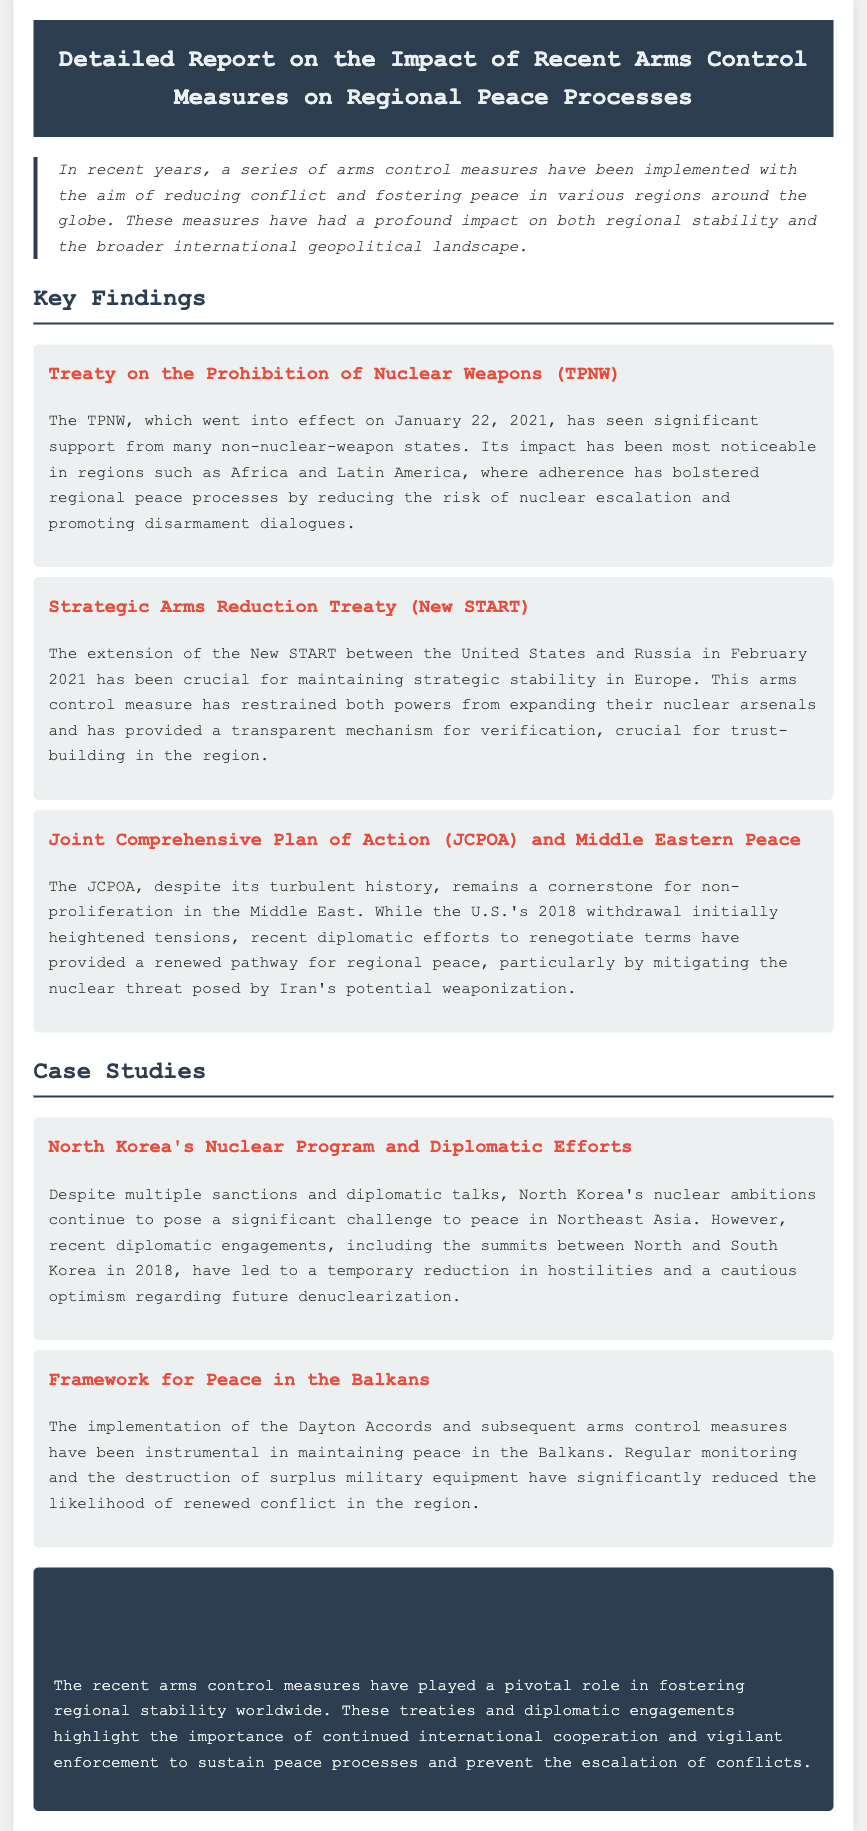what is the title of the report? The title is clearly stated in the header of the document, which is about arms control measures and their impacts.
Answer: Detailed Report on the Impact of Recent Arms Control Measures on Regional Peace Processes when did the TPNW go into effect? The document lists the effective date of the Treaty on the Prohibition of Nuclear Weapons.
Answer: January 22, 2021 which treaty is crucial for maintaining strategic stability in Europe? The report identifies a specific treaty that plays a key role in strategic stability and provides details about its significance.
Answer: Strategic Arms Reduction Treaty (New START) what is a key finding about the JCPOA? The document summarizes the status and impact of the Joint Comprehensive Plan of Action, particularly regarding its role in the Middle East.
Answer: A cornerstone for non-proliferation in the Middle East who are the two countries involved in the diplomatic efforts mentioned in the case study on North Korea? The case study mentions specific countries that are involved in diplomatic engagements related to North Korea's nuclear program.
Answer: North and South Korea what role have the Dayton Accords had in the Balkans? The document explains the significance of the Dayton Accords concerning peace maintenance in a specific region.
Answer: Instrumental in maintaining peace what do arms control measures aim to achieve? The introductory paragraph summarizes the overarching goals of the arms control measures discussed in the report.
Answer: Reducing conflict and fostering peace how has the New START treaty contributed to trust-building? The report describes how a specific treaty contributes to trust within the context of global arms control.
Answer: Provided a transparent mechanism for verification what is the main conclusion of the report? The conclusion section encapsulates the overall findings and implications of the arms control measures discussed.
Answer: Played a pivotal role in fostering regional stability worldwide 